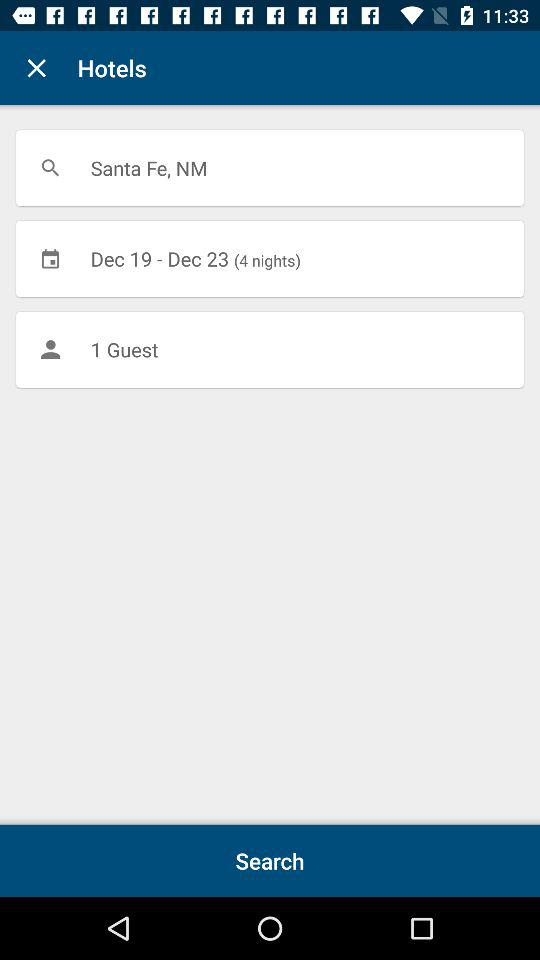What location is shown on the screen? The location is Santa Fe, NM. 